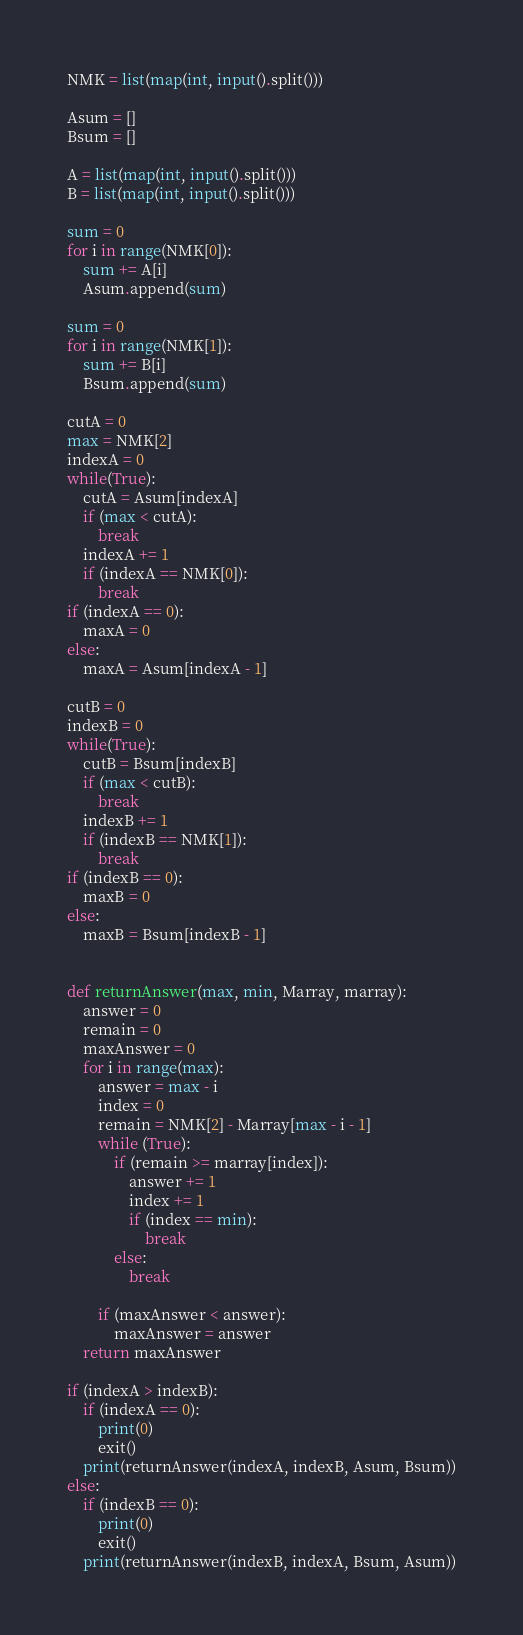<code> <loc_0><loc_0><loc_500><loc_500><_Python_>NMK = list(map(int, input().split()))

Asum = []
Bsum = []

A = list(map(int, input().split()))
B = list(map(int, input().split()))

sum = 0
for i in range(NMK[0]):
    sum += A[i]
    Asum.append(sum)

sum = 0
for i in range(NMK[1]):
    sum += B[i]
    Bsum.append(sum)

cutA = 0
max = NMK[2]
indexA = 0
while(True):
    cutA = Asum[indexA]
    if (max < cutA):
        break
    indexA += 1
    if (indexA == NMK[0]):
        break
if (indexA == 0):
    maxA = 0
else:
    maxA = Asum[indexA - 1]

cutB = 0
indexB = 0
while(True):
    cutB = Bsum[indexB]
    if (max < cutB):
        break
    indexB += 1
    if (indexB == NMK[1]):
        break
if (indexB == 0):
    maxB = 0
else:
    maxB = Bsum[indexB - 1]


def returnAnswer(max, min, Marray, marray):
    answer = 0
    remain = 0
    maxAnswer = 0
    for i in range(max):
        answer = max - i
        index = 0
        remain = NMK[2] - Marray[max - i - 1]
        while (True):
            if (remain >= marray[index]):
                answer += 1
                index += 1
                if (index == min):
                    break
            else:
                break

        if (maxAnswer < answer):
            maxAnswer = answer
    return maxAnswer

if (indexA > indexB):
    if (indexA == 0):
        print(0)
        exit()
    print(returnAnswer(indexA, indexB, Asum, Bsum))
else:
    if (indexB == 0):
        print(0)
        exit()
    print(returnAnswer(indexB, indexA, Bsum, Asum))</code> 